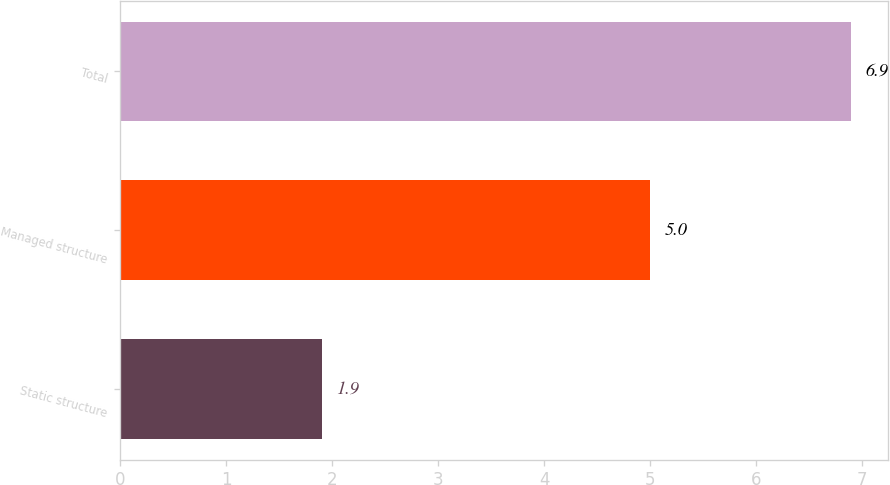Convert chart to OTSL. <chart><loc_0><loc_0><loc_500><loc_500><bar_chart><fcel>Static structure<fcel>Managed structure<fcel>Total<nl><fcel>1.9<fcel>5<fcel>6.9<nl></chart> 